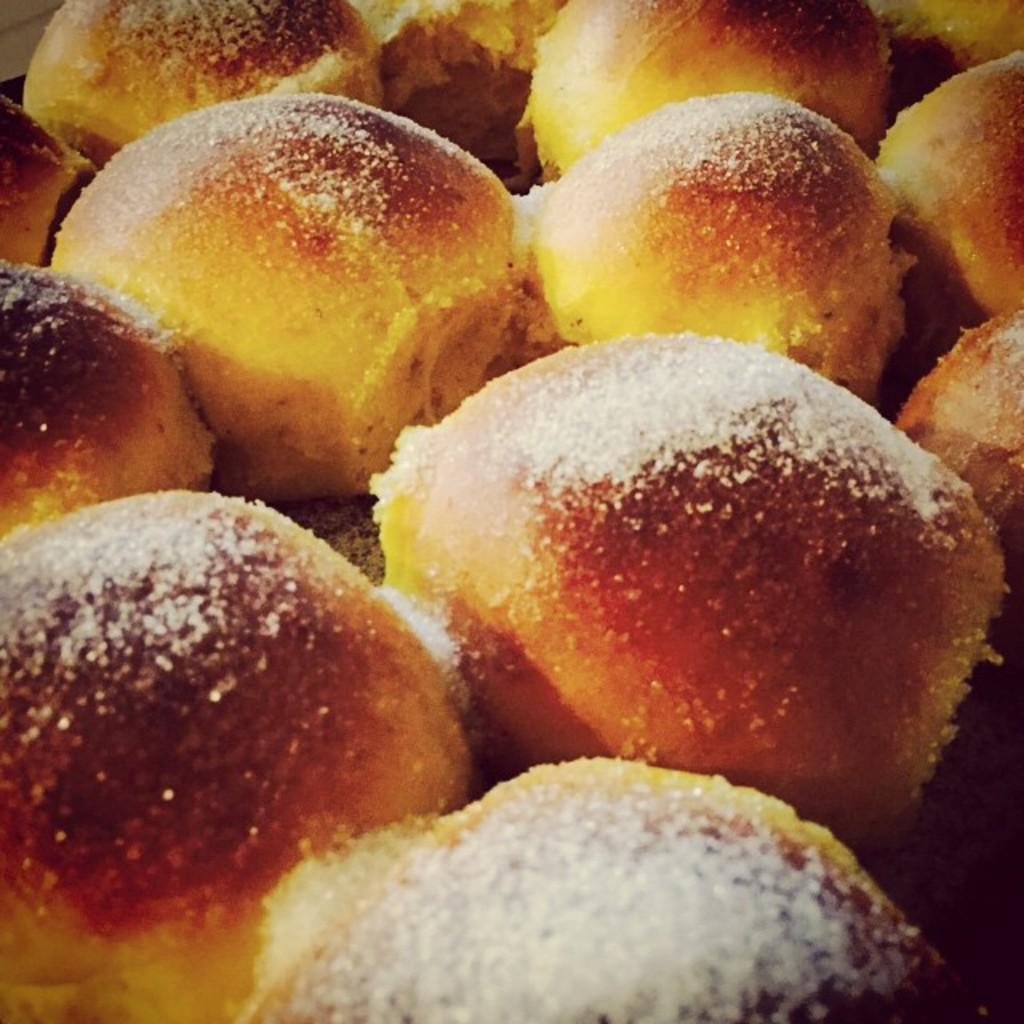What type of food is visible in the image? The food appears to be sweets. How many babies are crawling on the sweets in the image? There are no babies present in the image; it only shows sweets. 